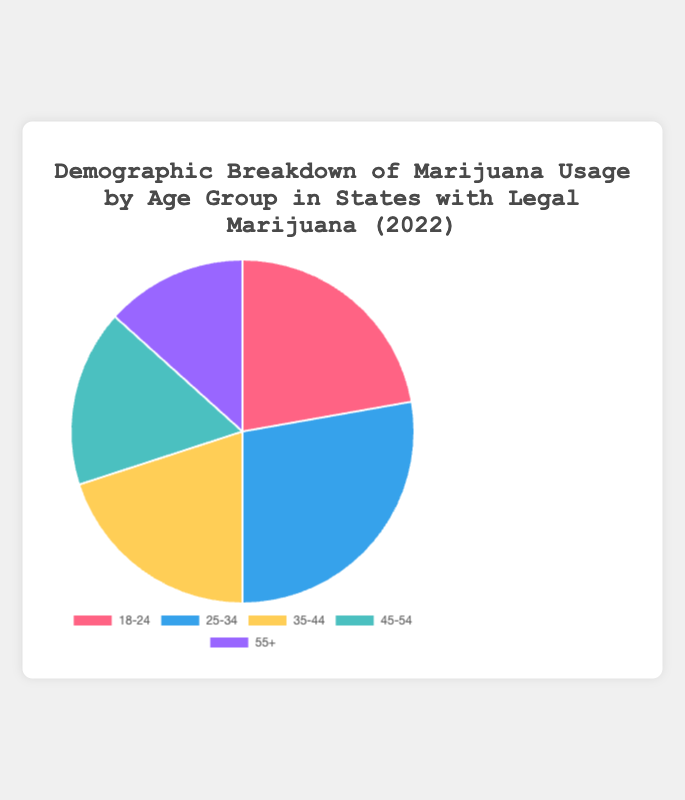What's the most used age group for marijuana usage? By looking at the chart, the segment with the highest percentage is for the 25-34 age group, as it has the largest area among the segments.
Answer: 25-34 Which age group uses marijuana less frequently than the 35-44 age group but more frequently than the 55+ age group? On the chart, the 45-54 age group is smaller than the 35-44 segment and larger than the 55+ segment.
Answer: 45-54 What is the combined percentage of marijuana usage for the age groups 18-24 and 55+? The percentages for 18-24 and 55+ are 20% and 12%, respectively. Adding them together gives 20% + 12% = 32%.
Answer: 32% Which age group has the smallest percentage of marijuana usage? The smallest segment in the chart corresponds to the 55+ age group.
Answer: 55+ What is the difference in marijuana usage percentage between the 25-34 and 45-54 age groups? The chart shows that the 25-34 group is at 25%, and the 45-54 group is at 15%. The difference is 25% - 15% = 10%.
Answer: 10% Which age groups have marijuana usage percentages that are within 5% of each other? The 18-24 (20%), 35-44 (18%), and 45-54 (15%) age groups all have percentages within a 5% range.
Answer: 18-24, 35-44, 45-54 What is the average percentage of marijuana usage across all age groups? Summing the percentages (20 + 25 + 18 + 15 + 12) gives 90. Dividing by the number of age groups (5) gives 90/5 = 18%.
Answer: 18% Which age group is represented by the red color in the chart? By looking at the color legend in the chart, the red segment corresponds to the 18-24 age group.
Answer: 18-24 How much more frequently does the 25-34 age group use marijuana compared to the 55+ age group? The percentages are 25% for 25-34 and 12% for 55+. The difference is 25% - 12% = 13%.
Answer: 13% Arrange the age groups in descending order of marijuana usage percentage. From the chart, the order is 25-34 (25%), 18-24 (20%), 35-44 (18%), 45-54 (15%), and 55+ (12%).
Answer: 25-34, 18-24, 35-44, 45-54, 55+ 